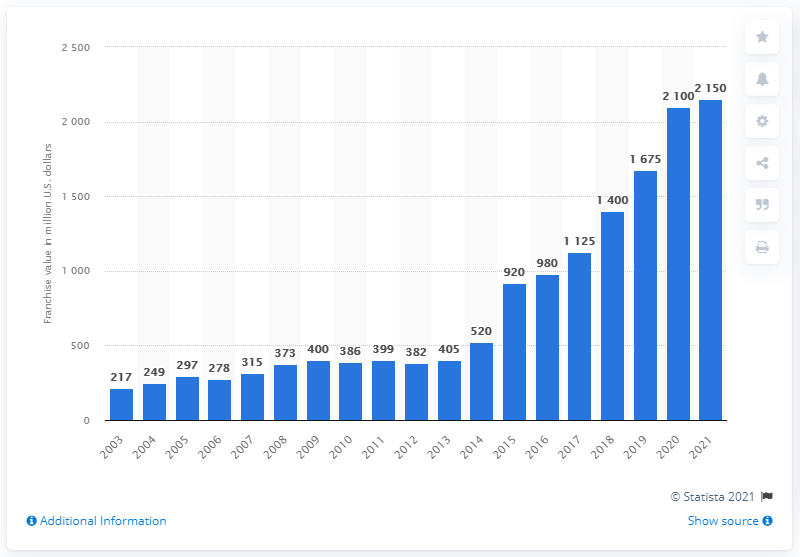Identify some key points in this picture. The estimated value of the Toronto Raptors in 2021 was $2,150. 